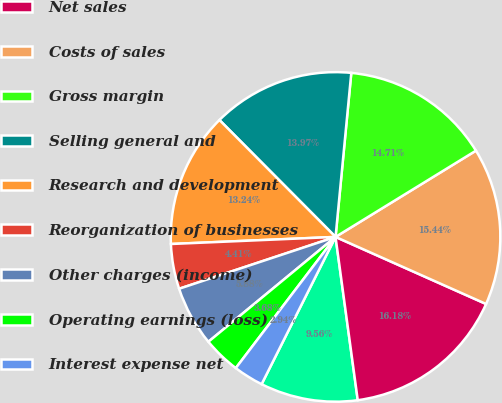Convert chart. <chart><loc_0><loc_0><loc_500><loc_500><pie_chart><fcel>(In millions except per share<fcel>Net sales<fcel>Costs of sales<fcel>Gross margin<fcel>Selling general and<fcel>Research and development<fcel>Reorganization of businesses<fcel>Other charges (income)<fcel>Operating earnings (loss)<fcel>Interest expense net<nl><fcel>9.56%<fcel>16.18%<fcel>15.44%<fcel>14.71%<fcel>13.97%<fcel>13.24%<fcel>4.41%<fcel>5.88%<fcel>3.68%<fcel>2.94%<nl></chart> 